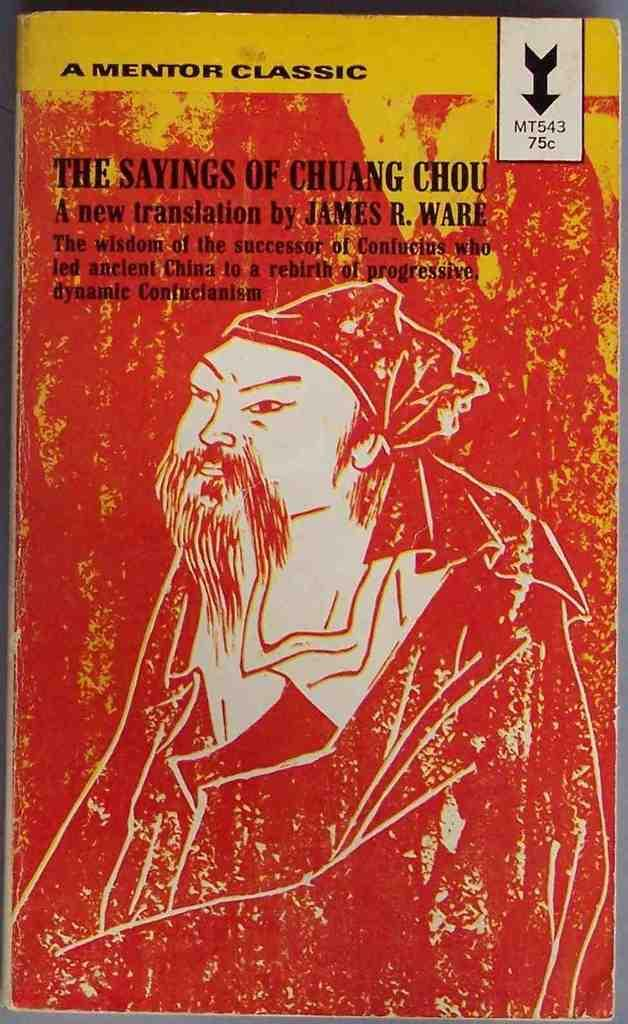Provide a one-sentence caption for the provided image. A red book titled The Sayings of Chuang Chou. 